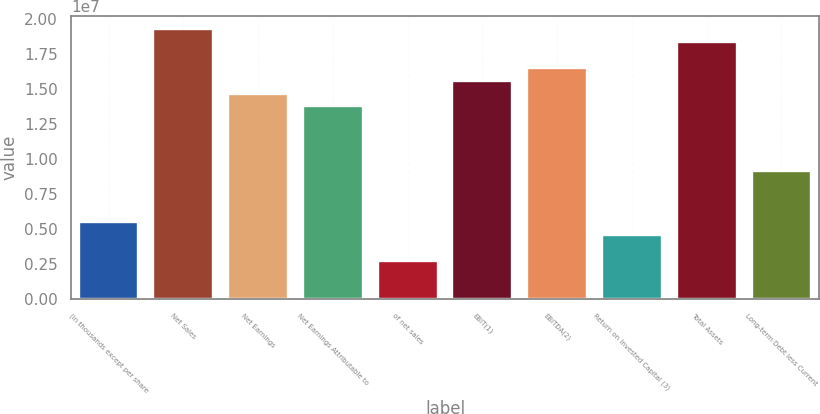<chart> <loc_0><loc_0><loc_500><loc_500><bar_chart><fcel>(in thousands except per share<fcel>Net Sales<fcel>Net Earnings<fcel>Net Earnings Attributable to<fcel>of net sales<fcel>EBIT(1)<fcel>EBITDA(2)<fcel>Return on Invested Capital (3)<fcel>Total Assets<fcel>Long-term Debt less Current<nl><fcel>5.50051e+06<fcel>1.92518e+07<fcel>1.4668e+07<fcel>1.37513e+07<fcel>2.75026e+06<fcel>1.55848e+07<fcel>1.65015e+07<fcel>4.58376e+06<fcel>1.8335e+07<fcel>9.16752e+06<nl></chart> 